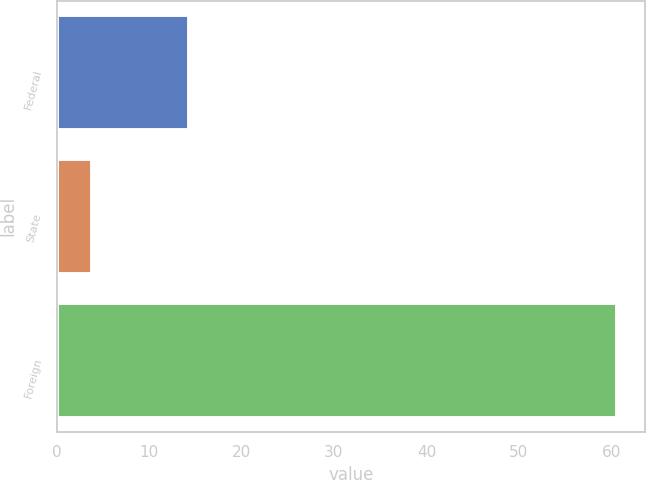Convert chart to OTSL. <chart><loc_0><loc_0><loc_500><loc_500><bar_chart><fcel>Federal<fcel>State<fcel>Foreign<nl><fcel>14.3<fcel>3.8<fcel>60.6<nl></chart> 